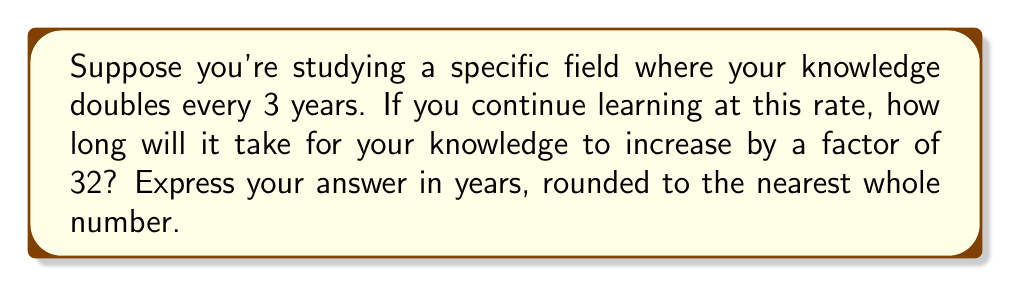Provide a solution to this math problem. Let's approach this step-by-step:

1) First, we need to understand what it means for knowledge to increase by a factor of 32. This can be expressed as:

   $32 = 2^5$

2) This means we're looking for how long it takes for knowledge to double 5 times.

3) We're given that knowledge doubles every 3 years. So we can set up the equation:

   $t = 3 * 5$

   Where $t$ is the time we're looking for.

4) Calculating:

   $t = 3 * 5 = 15$

5) Therefore, it will take 15 years for knowledge to increase by a factor of 32.

Alternatively, we could solve this using logarithms:

1) Let $y$ be the factor by which knowledge increases, and $t$ be the time in years.

2) We can express this relationship as:

   $y = 2^{\frac{t}{3}}$

3) We want to find $t$ when $y = 32$. So we can write:

   $32 = 2^{\frac{t}{3}}$

4) Taking the logarithm of both sides:

   $\log_2 32 = \log_2 (2^{\frac{t}{3}})$

5) Using the logarithm property $\log_a (a^x) = x$:

   $\log_2 32 = \frac{t}{3}$

6) We know that $\log_2 32 = 5$, so:

   $5 = \frac{t}{3}$

7) Solving for $t$:

   $t = 3 * 5 = 15$

Thus, we arrive at the same answer: 15 years.
Answer: 15 years 